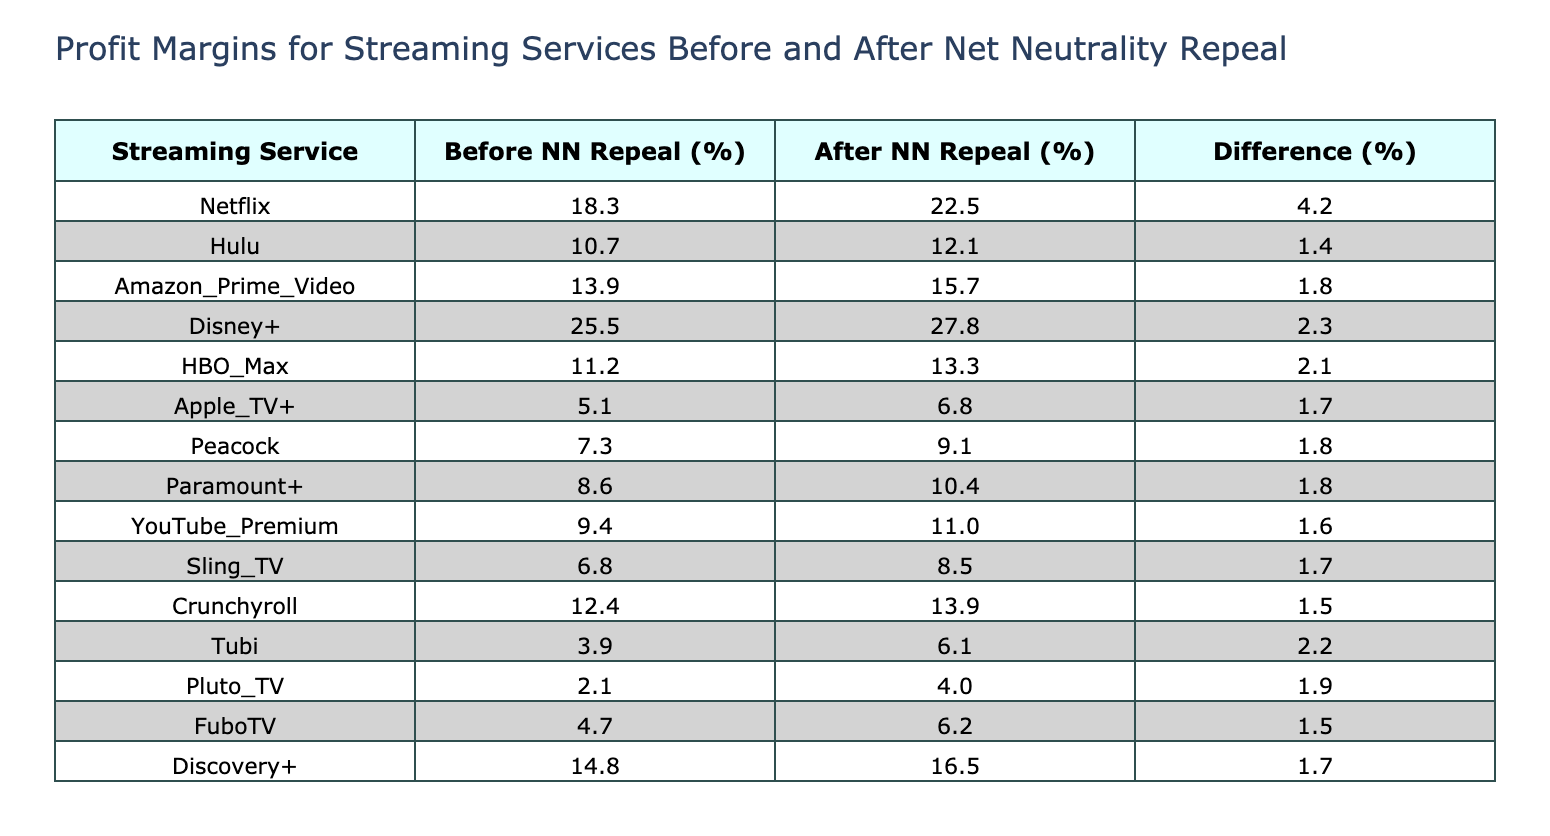What is the profit margin percentage for Netflix after the net neutrality repeal? Referring to the table, Netflix has a profit margin percentage of 22.5% after the net neutrality repeal.
Answer: 22.5% Which streaming service showed the highest profit margin before the net neutrality repeal? According to the table, Disney+ had the highest profit margin before the repeal at 25.5%.
Answer: Disney+ What is the profit margin difference for Hulu before and after the net neutrality repeal? For Hulu, the profit margin before the repeal is 10.7% and after is 12.1%. The difference is calculated by subtracting 10.7 from 12.1, which equals 1.4%.
Answer: 1.4% Did any streaming service have a profit margin below 5% after the net neutrality repeal? Looking at the table, all streaming services show profit margins above 5% after the repeal. Thus, the statement is false.
Answer: No What is the average profit margin for all streaming services after the net neutrality repeal? First, we sum the profit margins after the repeal: 22.5 + 12.1 + 15.7 + 27.8 + 13.3 + 6.8 + 9.1 + 10.4 + 11.0 + 8.5 + 13.9 + 6.1 + 4.0 + 6.2 + 16.5 = 309.3%. There are 15 services, so the average is 309.3% / 15 = 20.62%.
Answer: 20.62% Which streaming service has the smallest increase in profit margin after the net neutrality repeal? The smallest increase in profit margin can be determined by comparing the differences. In the table, Peacock's margin increased from 7.3% to 9.1%, which is a difference of 1.8%, the smallest in the entire dataset.
Answer: Peacock 